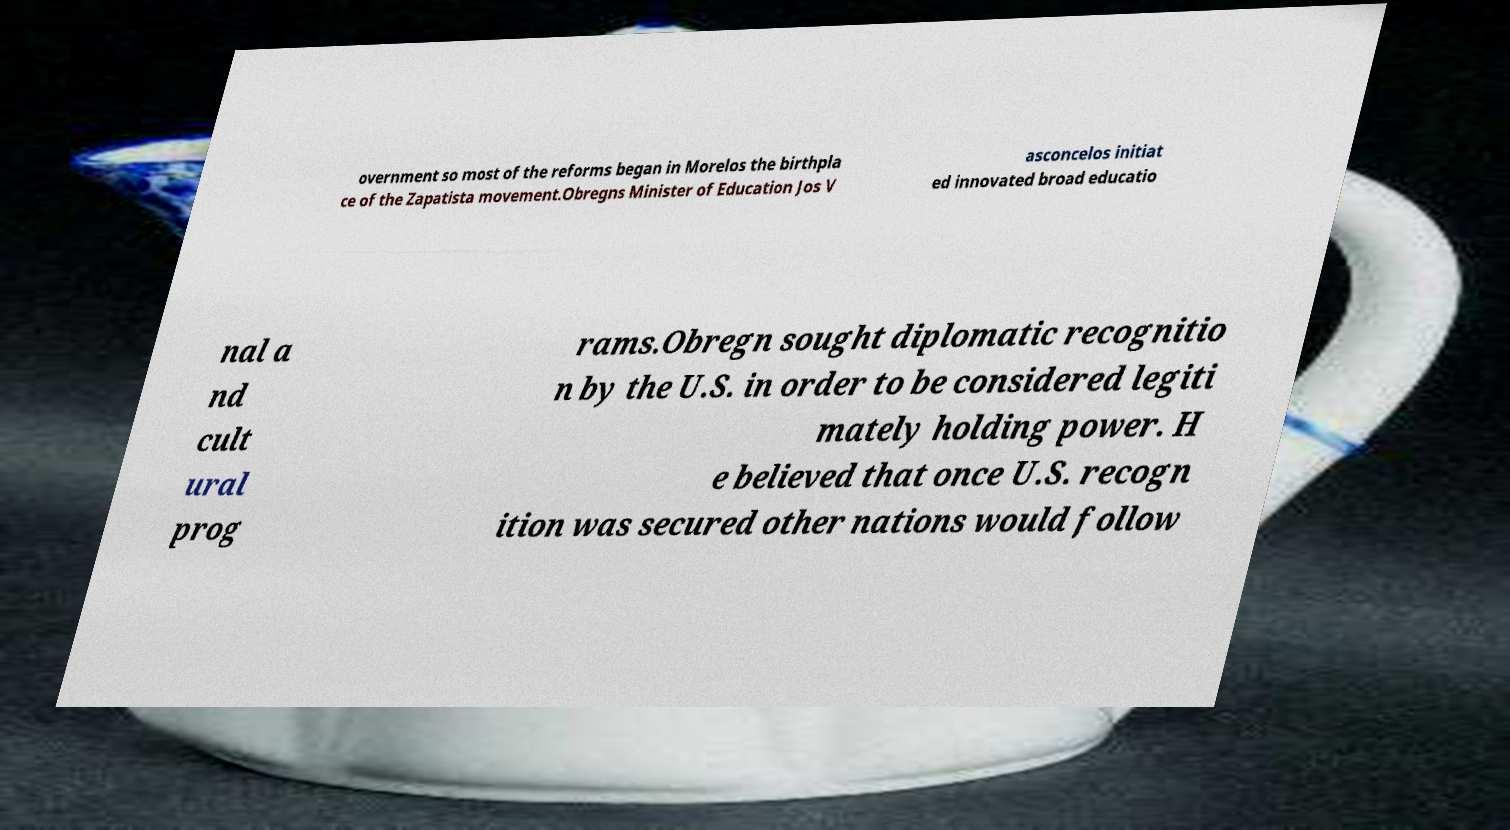What messages or text are displayed in this image? I need them in a readable, typed format. overnment so most of the reforms began in Morelos the birthpla ce of the Zapatista movement.Obregns Minister of Education Jos V asconcelos initiat ed innovated broad educatio nal a nd cult ural prog rams.Obregn sought diplomatic recognitio n by the U.S. in order to be considered legiti mately holding power. H e believed that once U.S. recogn ition was secured other nations would follow 